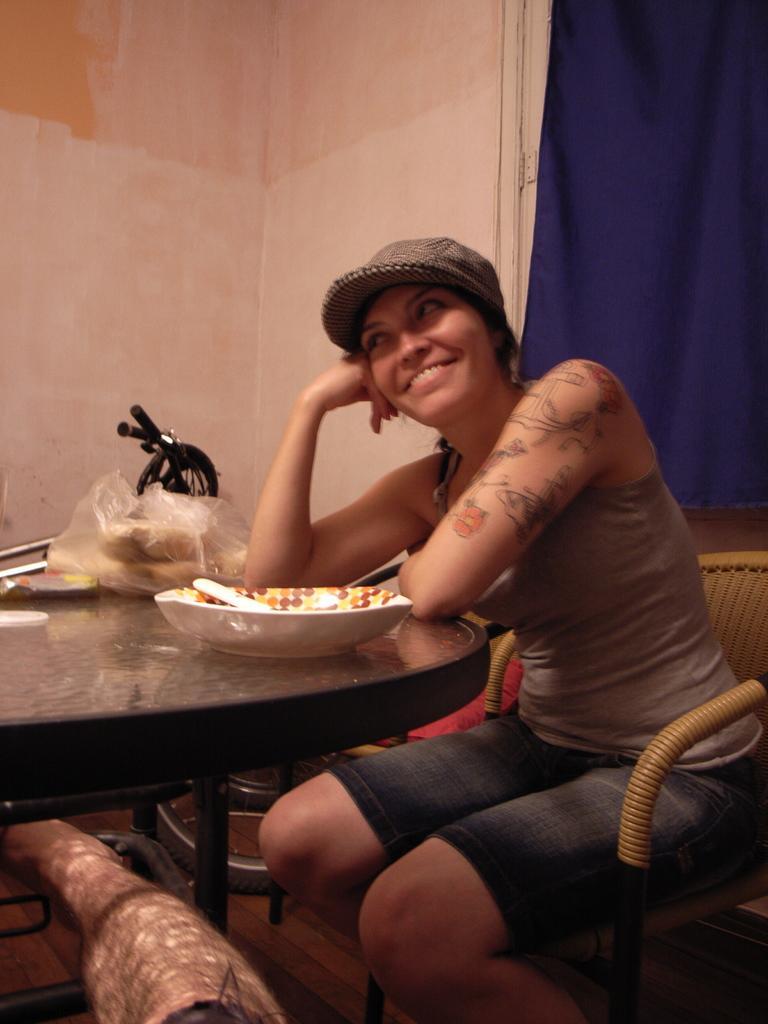Please provide a concise description of this image. This is the woman sitting on the chair and smiling. She wore a cap., T-shirt and a short. This looks like a table with a bowl, bag and few other things on it. Here is a curtain hanging. This is the wall. I think this is a vehicle. 